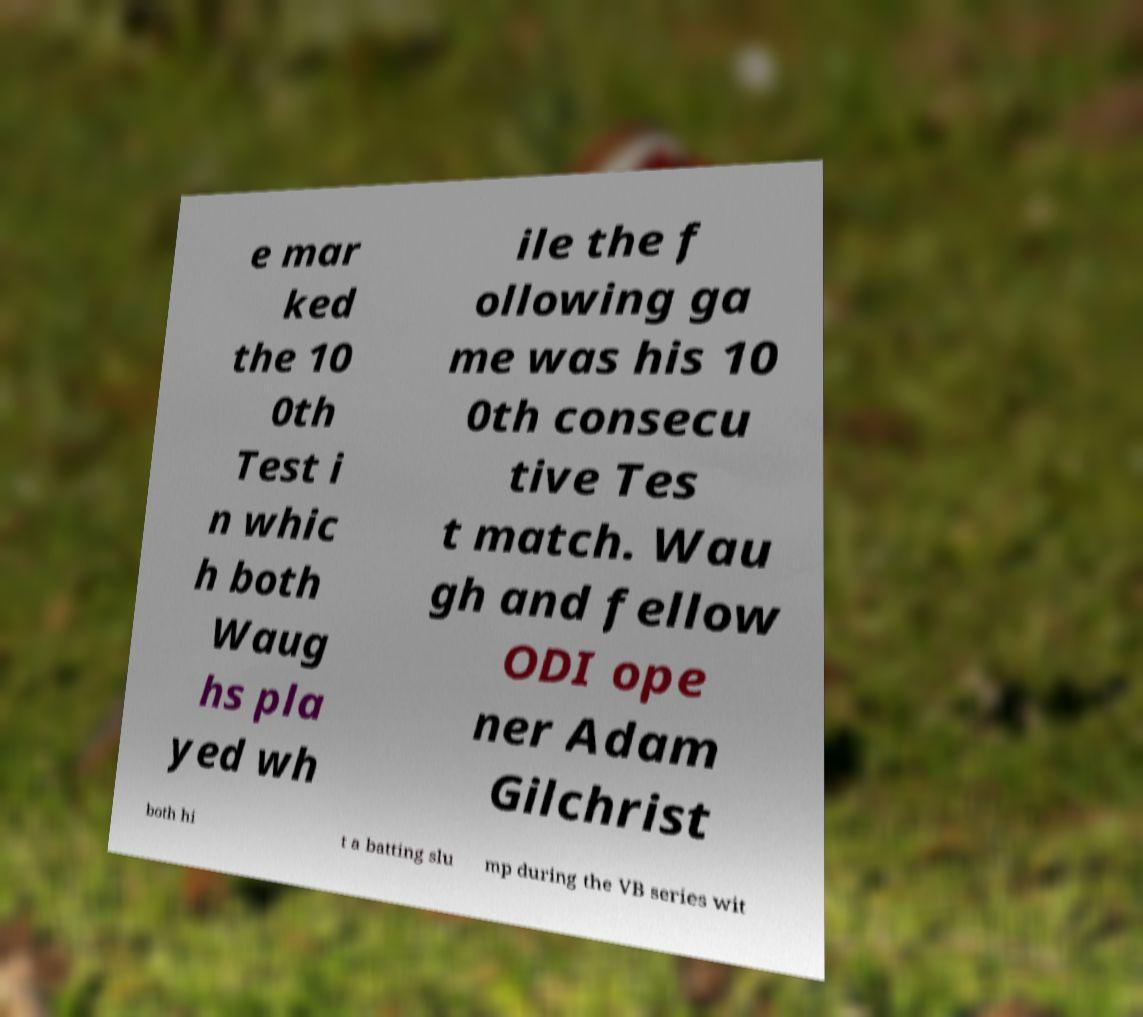There's text embedded in this image that I need extracted. Can you transcribe it verbatim? e mar ked the 10 0th Test i n whic h both Waug hs pla yed wh ile the f ollowing ga me was his 10 0th consecu tive Tes t match. Wau gh and fellow ODI ope ner Adam Gilchrist both hi t a batting slu mp during the VB series wit 